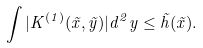<formula> <loc_0><loc_0><loc_500><loc_500>\int | K ^ { ( 1 ) } ( \vec { x } , \vec { y } ) | d ^ { 2 } y \leq \tilde { h } ( \vec { x } ) .</formula> 